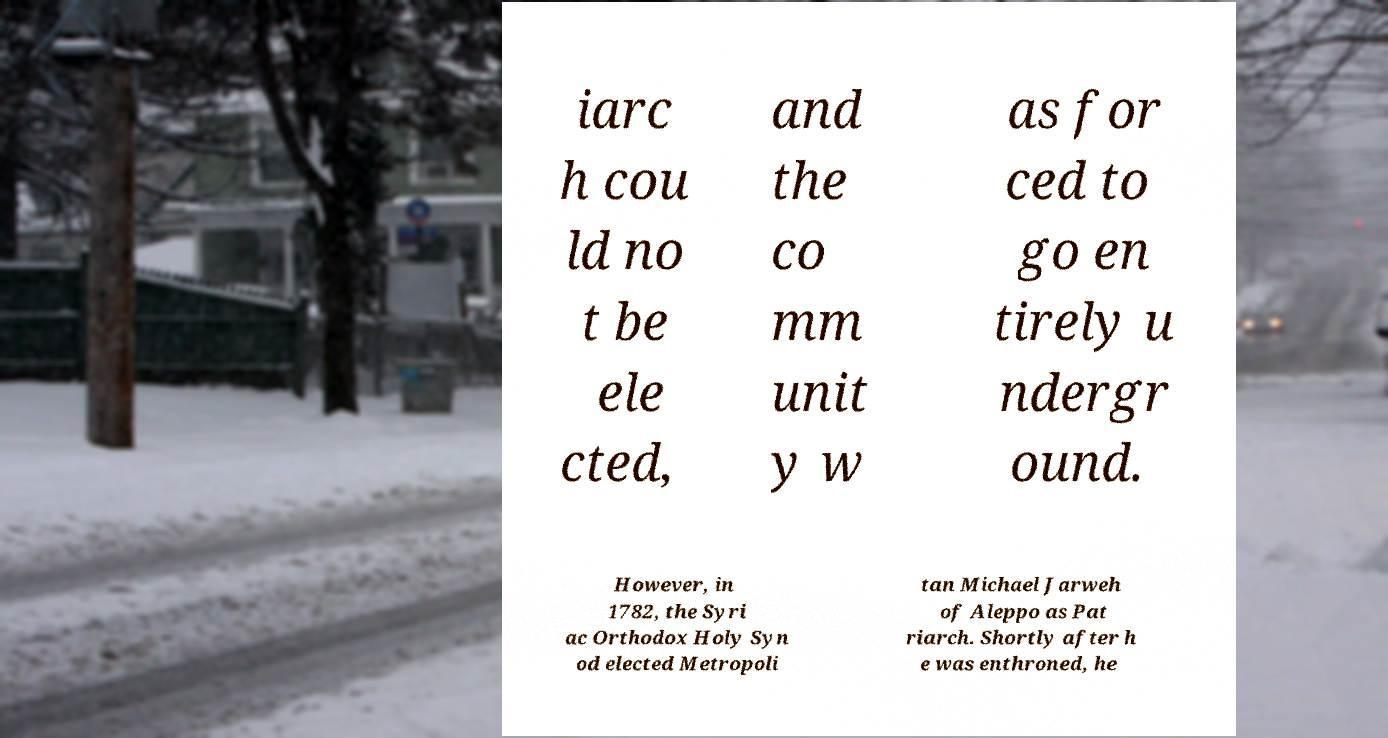Could you assist in decoding the text presented in this image and type it out clearly? iarc h cou ld no t be ele cted, and the co mm unit y w as for ced to go en tirely u ndergr ound. However, in 1782, the Syri ac Orthodox Holy Syn od elected Metropoli tan Michael Jarweh of Aleppo as Pat riarch. Shortly after h e was enthroned, he 